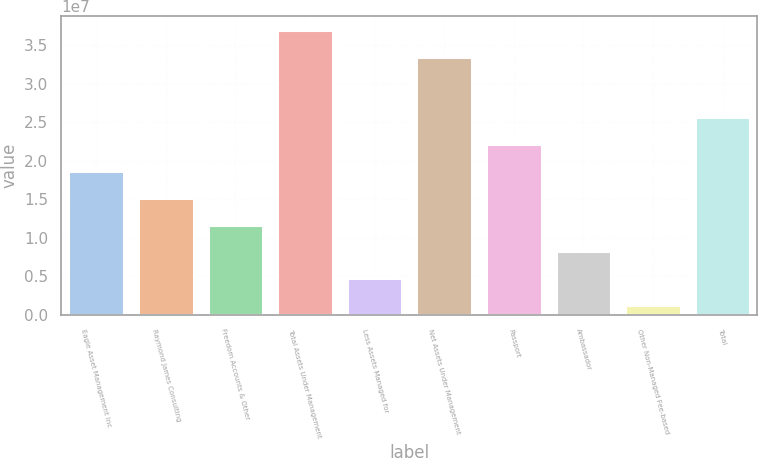Convert chart. <chart><loc_0><loc_0><loc_500><loc_500><bar_chart><fcel>Eagle Asset Management Inc<fcel>Raymond James Consulting<fcel>Freedom Accounts & Other<fcel>Total Assets Under Management<fcel>Less Assets Managed for<fcel>Net Assets Under Management<fcel>Passport<fcel>Ambassador<fcel>Other Non-Managed Fee-based<fcel>Total<nl><fcel>1.86647e+07<fcel>1.51876e+07<fcel>1.17104e+07<fcel>3.69494e+07<fcel>4.75615e+06<fcel>3.34722e+07<fcel>2.21419e+07<fcel>8.2333e+06<fcel>1.279e+06<fcel>2.5619e+07<nl></chart> 